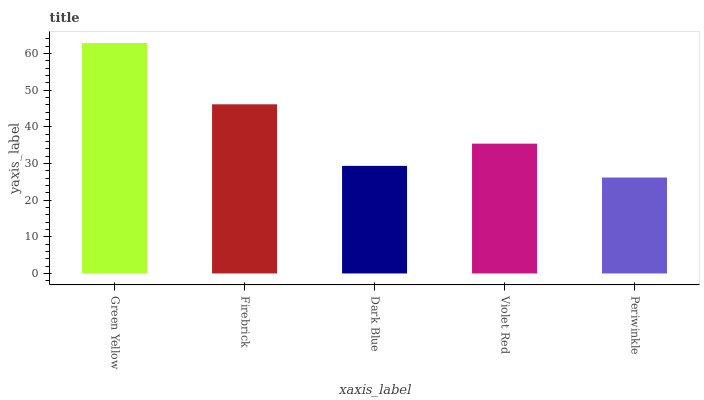Is Periwinkle the minimum?
Answer yes or no. Yes. Is Green Yellow the maximum?
Answer yes or no. Yes. Is Firebrick the minimum?
Answer yes or no. No. Is Firebrick the maximum?
Answer yes or no. No. Is Green Yellow greater than Firebrick?
Answer yes or no. Yes. Is Firebrick less than Green Yellow?
Answer yes or no. Yes. Is Firebrick greater than Green Yellow?
Answer yes or no. No. Is Green Yellow less than Firebrick?
Answer yes or no. No. Is Violet Red the high median?
Answer yes or no. Yes. Is Violet Red the low median?
Answer yes or no. Yes. Is Dark Blue the high median?
Answer yes or no. No. Is Periwinkle the low median?
Answer yes or no. No. 